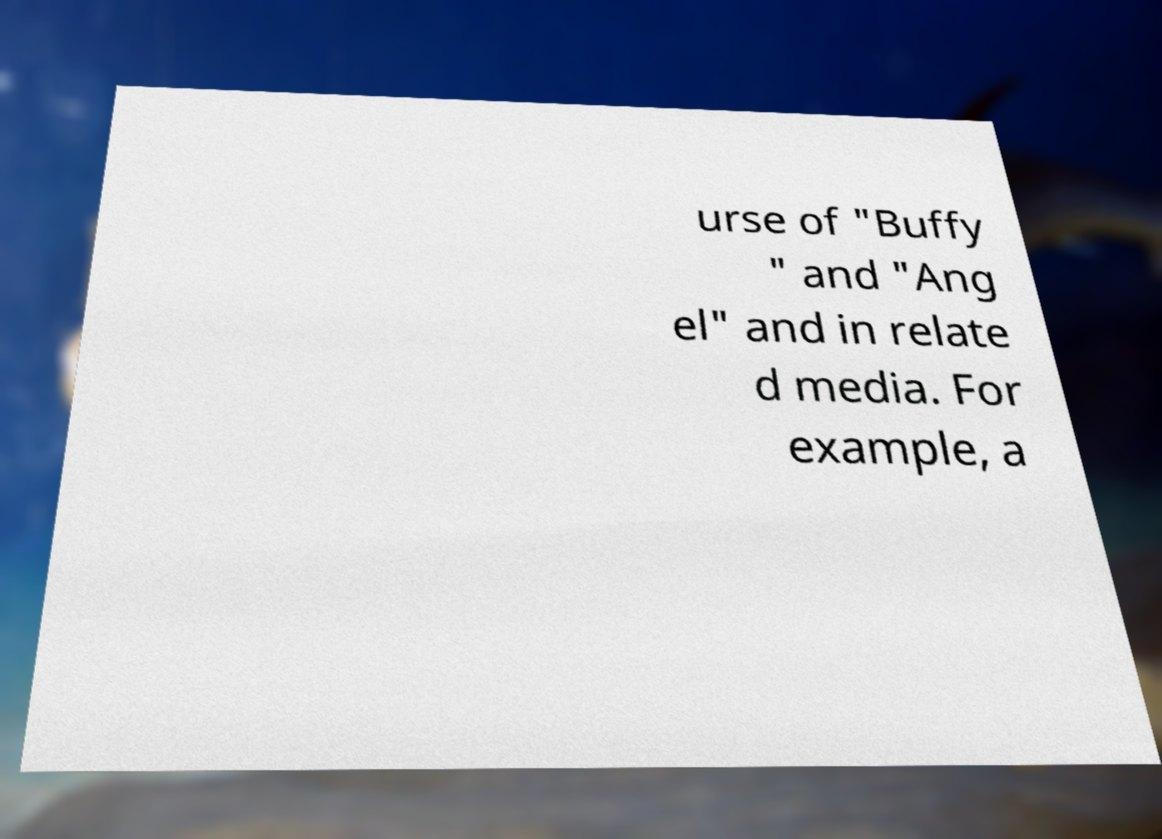What messages or text are displayed in this image? I need them in a readable, typed format. urse of "Buffy " and "Ang el" and in relate d media. For example, a 